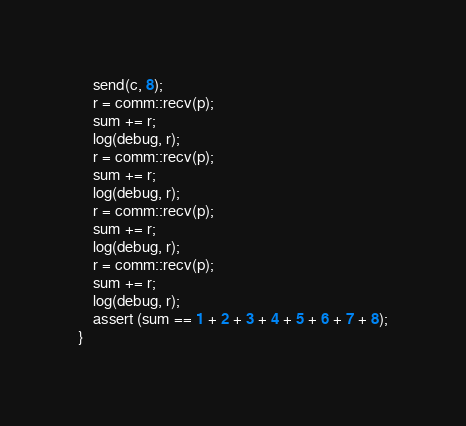<code> <loc_0><loc_0><loc_500><loc_500><_Rust_>    send(c, 8);
    r = comm::recv(p);
    sum += r;
    log(debug, r);
    r = comm::recv(p);
    sum += r;
    log(debug, r);
    r = comm::recv(p);
    sum += r;
    log(debug, r);
    r = comm::recv(p);
    sum += r;
    log(debug, r);
    assert (sum == 1 + 2 + 3 + 4 + 5 + 6 + 7 + 8);
}
</code> 